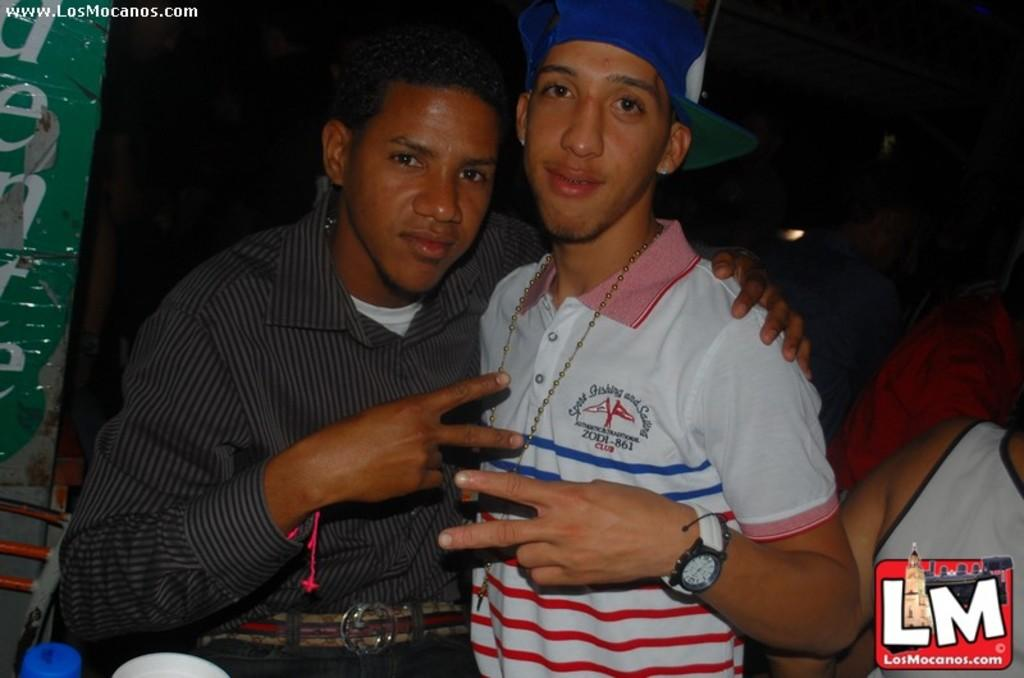Provide a one-sentence caption for the provided image. Two guys pose for a picture together, brought to you by www.LosMocanos.com. 